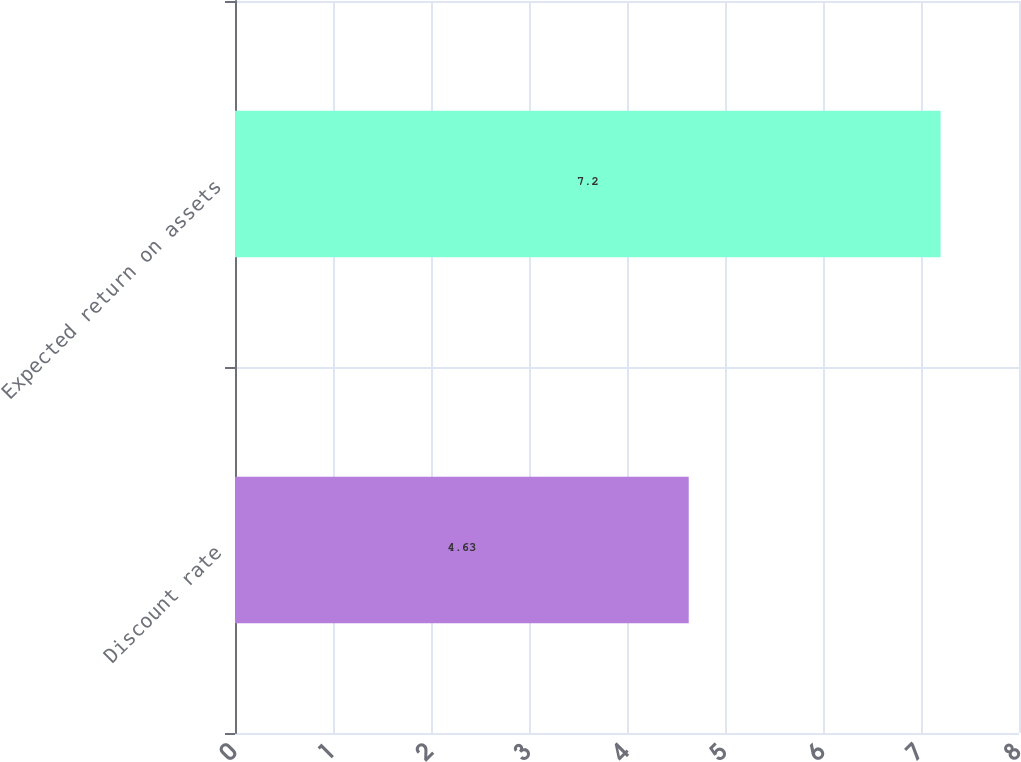Convert chart. <chart><loc_0><loc_0><loc_500><loc_500><bar_chart><fcel>Discount rate<fcel>Expected return on assets<nl><fcel>4.63<fcel>7.2<nl></chart> 